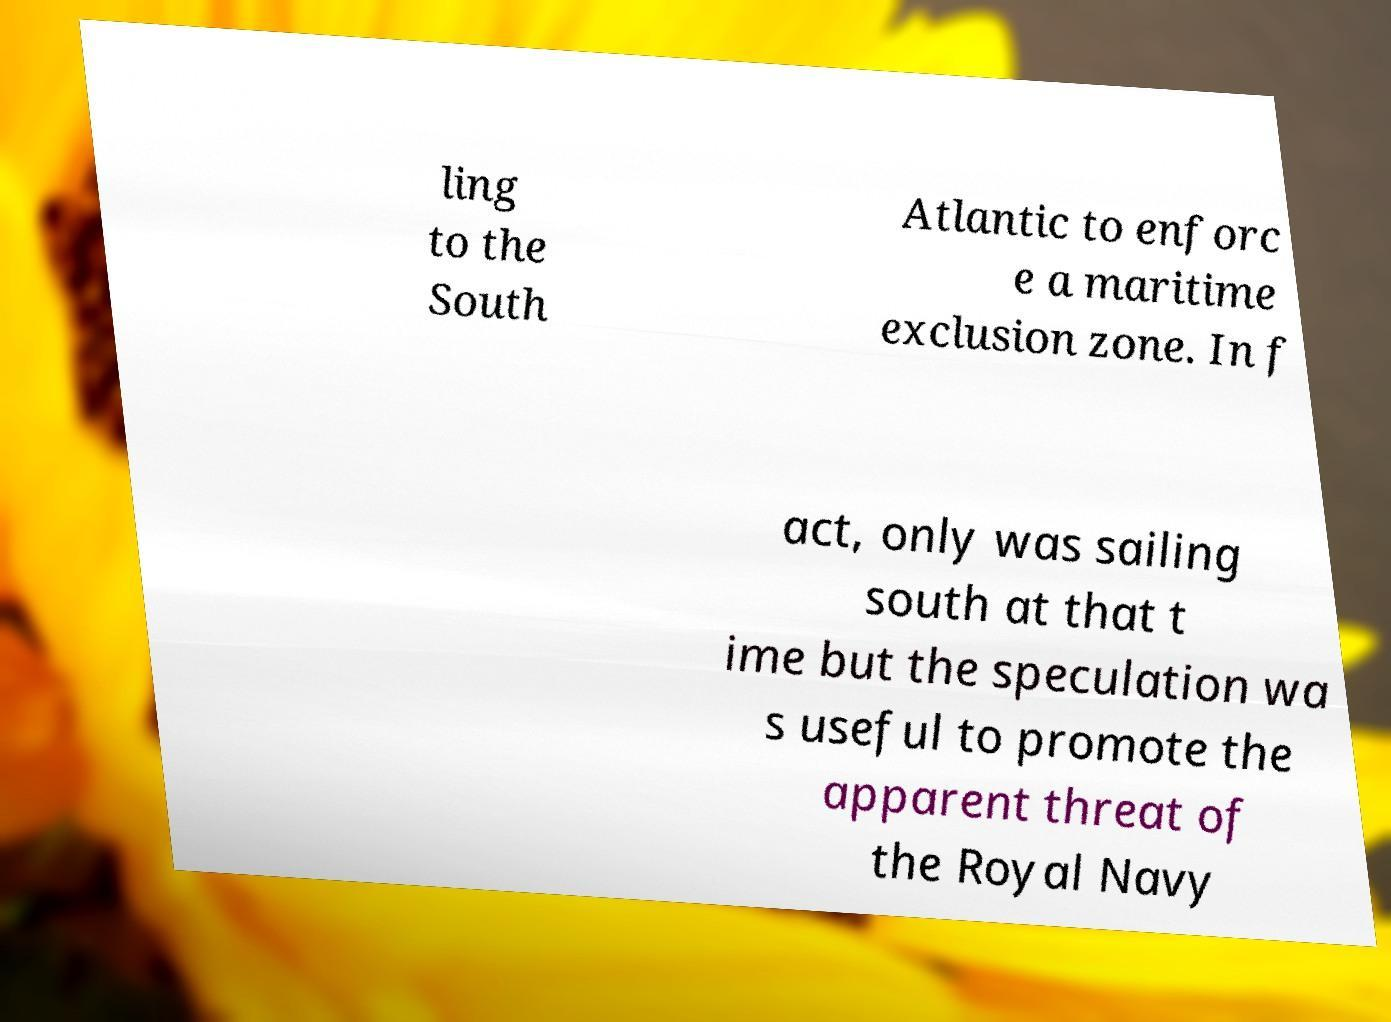Please read and relay the text visible in this image. What does it say? ling to the South Atlantic to enforc e a maritime exclusion zone. In f act, only was sailing south at that t ime but the speculation wa s useful to promote the apparent threat of the Royal Navy 